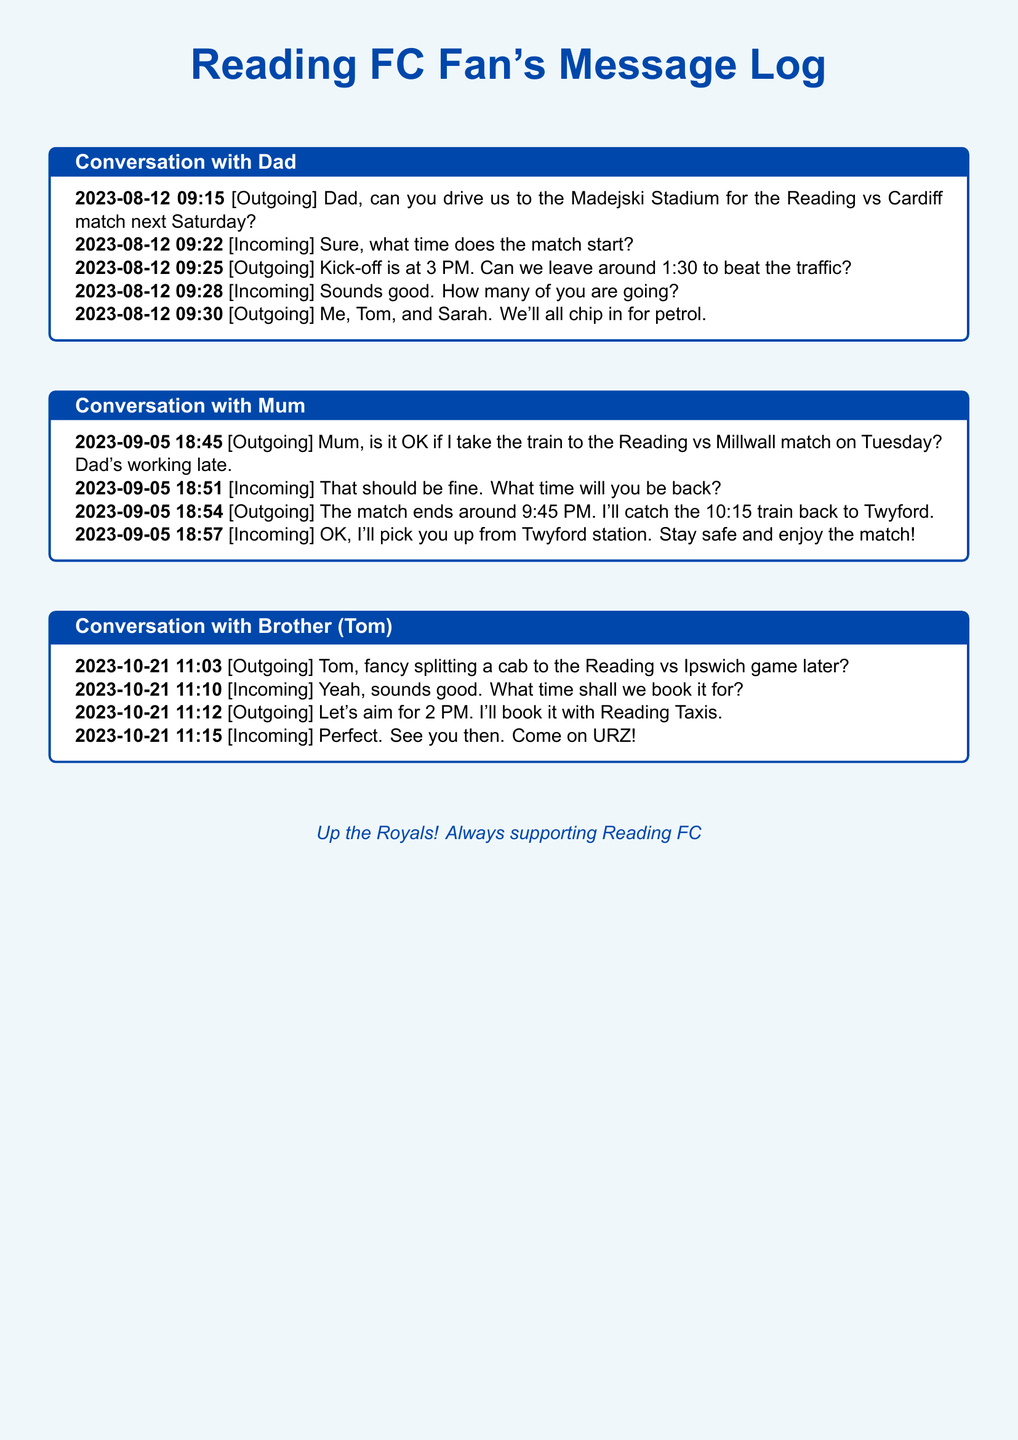What is the date of the match against Cardiff? The conversation with Dad mentions the match against Cardiff on the upcoming Saturday, which is on August 19, 2023.
Answer: August 19, 2023 What time is the Reading vs Millwall match scheduled to start? The conversation with Mum indicates that the match against Millwall starts at 7:45 PM on Tuesday.
Answer: 7:45 PM Who is going to the Reading vs Cardiff match? The outgoing message specifies that the sender, Tom, and Sarah will attend the match.
Answer: Me, Tom, and Sarah What time will the cab be booked for the match against Ipswich? The conversation with Tom states that they will aim to book the cab for 2 PM.
Answer: 2 PM How will the sender get back from the Reading vs Millwall match? The sender plans to catch the 10:15 train back to Twyford after the match.
Answer: 10:15 train What does "URZ" stand for? "URZ" refers to a chant or phrase used by Reading FC fans, representing "Up the Royals."
Answer: Up the Royals Who will pick up the sender from the train station after the Millwall match? The incoming message from Mum indicates that she will pick up the sender.
Answer: Mum How many people are planning to chip in for petrol for the Cardiff match? The outgoing message mentions that three people will chip in for petrol.
Answer: Three 